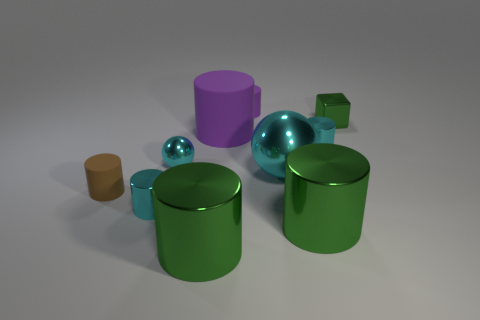Subtract all cyan cylinders. How many cylinders are left? 5 Subtract all cyan blocks. How many cyan cylinders are left? 2 Subtract 5 cylinders. How many cylinders are left? 2 Subtract all green cylinders. How many cylinders are left? 5 Subtract all yellow cylinders. Subtract all yellow spheres. How many cylinders are left? 7 Subtract all spheres. How many objects are left? 8 Add 1 small metallic cylinders. How many small metallic cylinders are left? 3 Add 5 metallic cubes. How many metallic cubes exist? 6 Subtract 1 purple cylinders. How many objects are left? 9 Subtract all matte cylinders. Subtract all big metallic objects. How many objects are left? 4 